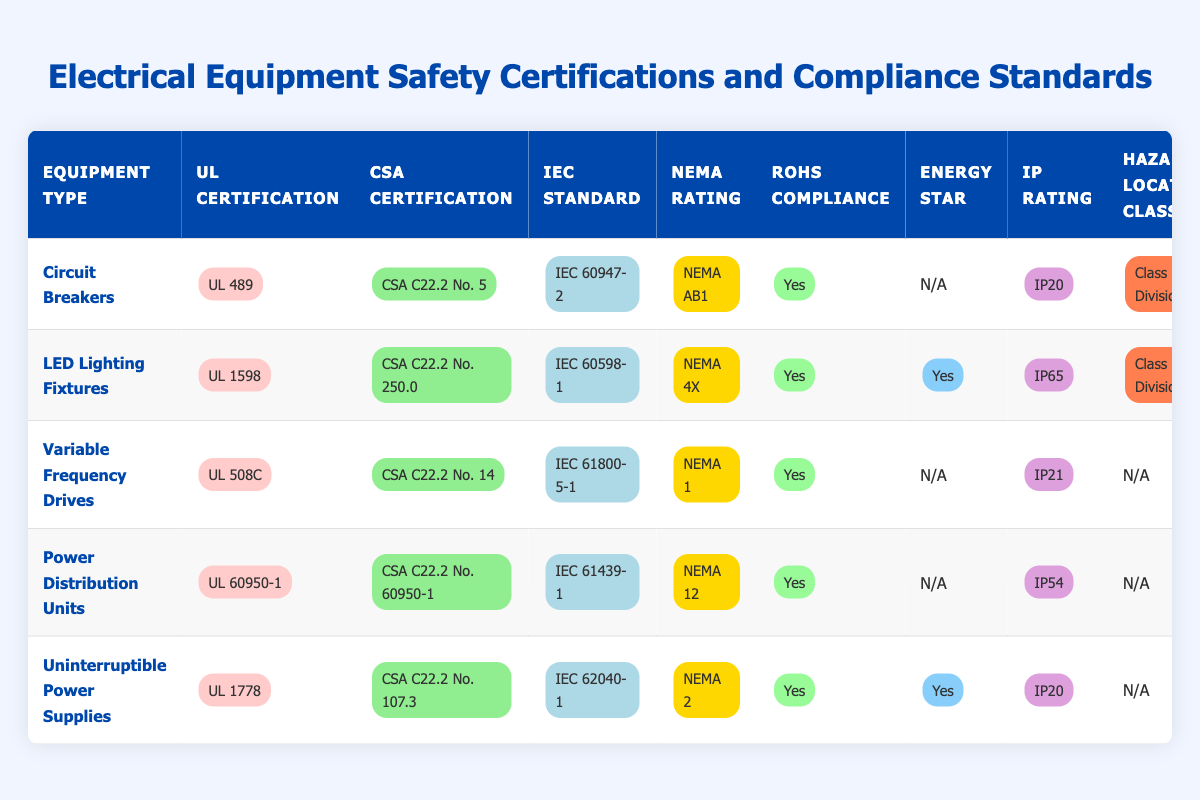What is the UL Certification for LED Lighting Fixtures? The table indicates that the UL Certification for LED Lighting Fixtures is listed as "UL 1598."
Answer: UL 1598 Which equipment type has the highest IP Rating? Comparing the IP Ratings from the table, LED Lighting Fixtures have the highest IP Rating of "IP65," which is higher than Circuit Breakers (IP20), Variable Frequency Drives (IP21), Power Distribution Units (IP54), and Uninterruptible Power Supplies (IP20).
Answer: IP65 Do Variable Frequency Drives have RoHS Compliance? The table specifies that Variable Frequency Drives are compliant with RoHS, as it is marked "Yes" in the corresponding column.
Answer: Yes How many equipment types have Energy Star certification? From the table, both LED Lighting Fixtures and Uninterruptible Power Supplies are marked as having Energy Star certification. Therefore, there are 2 types that meet this criterion.
Answer: 2 Which equipment type has the least hazardous location classification? The table shows that Variable Frequency Drives, Power Distribution Units, and Uninterruptible Power Supplies have "N/A" for Hazardous Location Class, indicating they are not classified for hazardous locations. The other equipment types have classifications for hazardous locations, so these three types have the least classification.
Answer: N/A What is the difference in NEMA Rating between Circuit Breakers and LED Lighting Fixtures? The NEMA Rating for Circuit Breakers is "NEMA AB1" and for LED Lighting Fixtures, it's "NEMA 4X." Considering the classifications, the difference demonstrates that LED fixtures have a higher protection rating against environmental factors than Circuit Breakers.
Answer: NEMA 4X - NEMA AB1 (higher rating) Are all equipment types listed RoHS compliant? According to the table, all equipment types except for Variable Frequency Drives, Power Distribution Units, and Uninterruptible Power Supplies show "Yes" for RoHS Compliance, confirming that not every type is compliant, as only those three listed are.
Answer: No Which IEC Standard is associated with Uninterruptible Power Supplies? The table outlines that the IEC Standard for Uninterruptible Power Supplies is "IEC 62040-1."
Answer: IEC 62040-1 What is the average NEMA Rating for the equipment types listed? The NEMA Ratings in the table are "NEMA AB1," "NEMA 4X," "NEMA 1," "NEMA 12," and "NEMA 2." These ratings are qualitative and cannot be averaged numerically as they are defined categorically rather than numerically. Therefore, an average cannot be computed in the mathematical sense.
Answer: Not applicable 